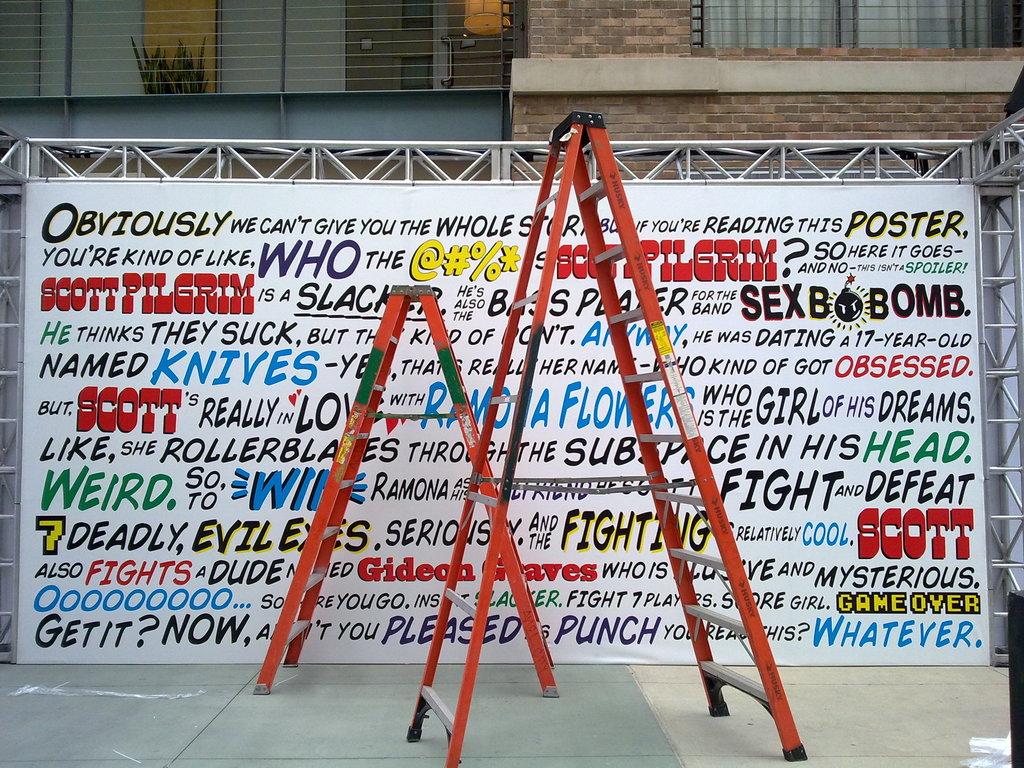What's one word on the poster?
Your response must be concise. Obviously. What is the first word on the poster?
Keep it short and to the point. Obviously. 